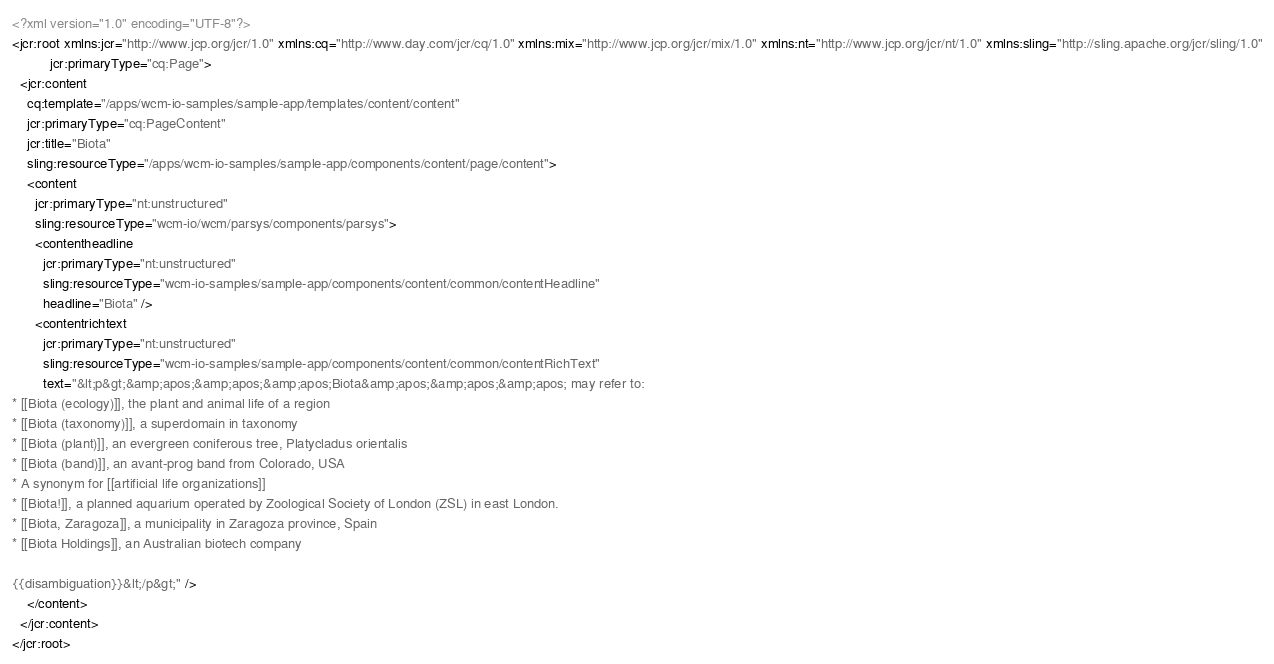Convert code to text. <code><loc_0><loc_0><loc_500><loc_500><_XML_><?xml version="1.0" encoding="UTF-8"?>
<jcr:root xmlns:jcr="http://www.jcp.org/jcr/1.0" xmlns:cq="http://www.day.com/jcr/cq/1.0" xmlns:mix="http://www.jcp.org/jcr/mix/1.0" xmlns:nt="http://www.jcp.org/jcr/nt/1.0" xmlns:sling="http://sling.apache.org/jcr/sling/1.0"
          jcr:primaryType="cq:Page">
  <jcr:content
    cq:template="/apps/wcm-io-samples/sample-app/templates/content/content"
    jcr:primaryType="cq:PageContent"
    jcr:title="Biota"
    sling:resourceType="/apps/wcm-io-samples/sample-app/components/content/page/content">
    <content
      jcr:primaryType="nt:unstructured"
      sling:resourceType="wcm-io/wcm/parsys/components/parsys">
      <contentheadline
        jcr:primaryType="nt:unstructured"
        sling:resourceType="wcm-io-samples/sample-app/components/content/common/contentHeadline"
        headline="Biota" />
      <contentrichtext
        jcr:primaryType="nt:unstructured"
        sling:resourceType="wcm-io-samples/sample-app/components/content/common/contentRichText"
        text="&lt;p&gt;&amp;apos;&amp;apos;&amp;apos;Biota&amp;apos;&amp;apos;&amp;apos; may refer to:
* [[Biota (ecology)]], the plant and animal life of a region
* [[Biota (taxonomy)]], a superdomain in taxonomy
* [[Biota (plant)]], an evergreen coniferous tree, Platycladus orientalis
* [[Biota (band)]], an avant-prog band from Colorado, USA
* A synonym for [[artificial life organizations]]
* [[Biota!]], a planned aquarium operated by Zoological Society of London (ZSL) in east London.
* [[Biota, Zaragoza]], a municipality in Zaragoza province, Spain
* [[Biota Holdings]], an Australian biotech company

{{disambiguation}}&lt;/p&gt;" />
    </content>
  </jcr:content>
</jcr:root>
</code> 